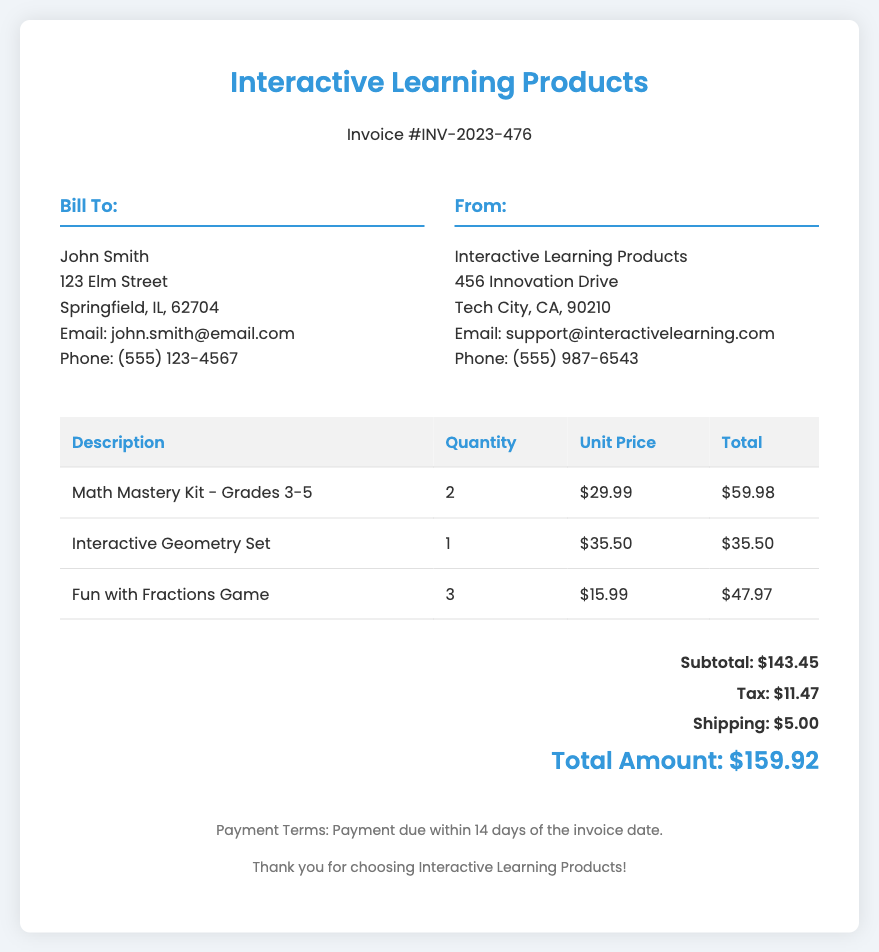What is the invoice number? The invoice number is listed prominently in the header of the document as "INV-2023-476."
Answer: INV-2023-476 Who is the recipient of the invoice? The recipient's name is specified under the "Bill To" section of the document, which is "John Smith."
Answer: John Smith What is the quantity of Math Mastery Kits sold? The quantity sold is detailed in the itemized product list, showing "2" for the Math Mastery Kit.
Answer: 2 What is the unit price of the Interactive Geometry Set? The unit price is provided in the table under the "Unit Price" column for the Interactive Geometry Set, which is "$35.50."
Answer: $35.50 What is the subtotal amount before tax and shipping? The subtotal is clearly stated in the total section as "$143.45."
Answer: $143.45 How much tax is applied to the sale? The tax amount is listed in the total section, indicated as "$11.47."
Answer: $11.47 What is the total amount charged for this invoice? The total amount charged is the final calculation listed at the bottom of the total section, which is "$159.92."
Answer: $159.92 What is the shipping cost for the order? The shipping cost is mentioned in the total section as "$5.00."
Answer: $5.00 What is the payment term specified in the document? The payment term is included in the footer, stating "Payment due within 14 days of the invoice date."
Answer: 14 days 